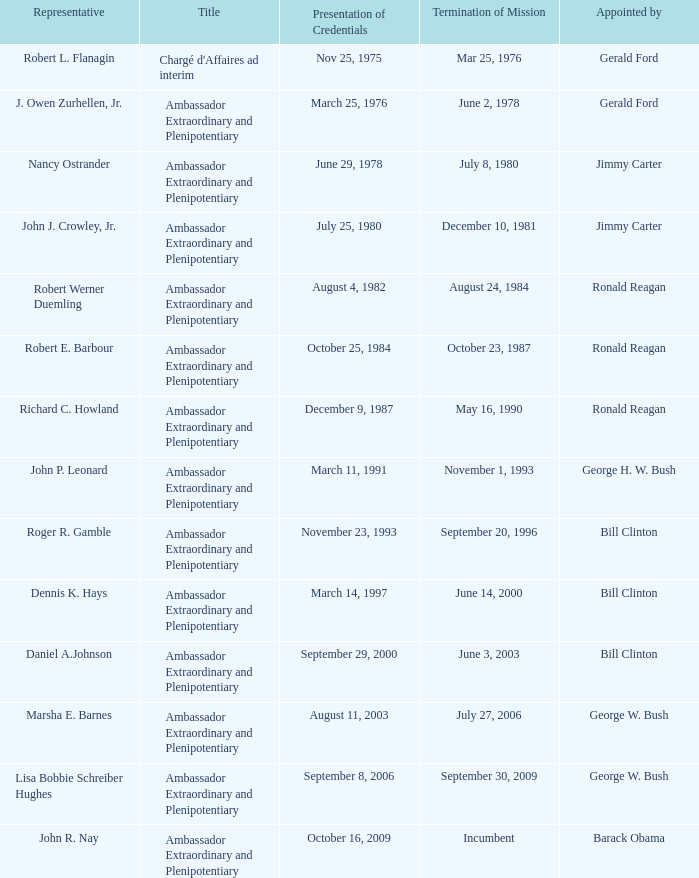On which date will marsha e. barnes' term as ambassador extraordinary and plenipotentiary come to an end? July 27, 2006. 